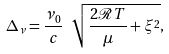<formula> <loc_0><loc_0><loc_500><loc_500>\Delta _ { \nu } = \frac { \nu _ { 0 } } { c } \ \sqrt { \frac { 2 \mathcal { R } T } { \mu } + \xi ^ { 2 } } ,</formula> 